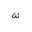<formula> <loc_0><loc_0><loc_500><loc_500>\omega</formula> 